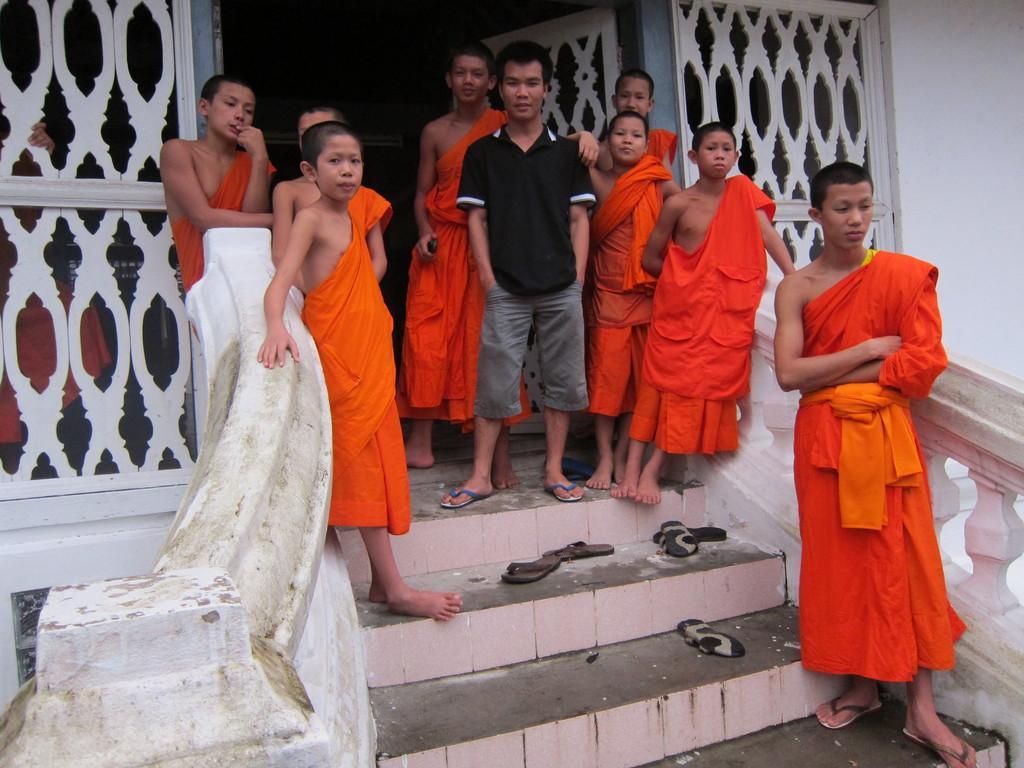Could you give a brief overview of what you see in this image? In the center of the image we can see some people are standing. In the background of the image we can see the wall, railing, stairs, footwear's. 